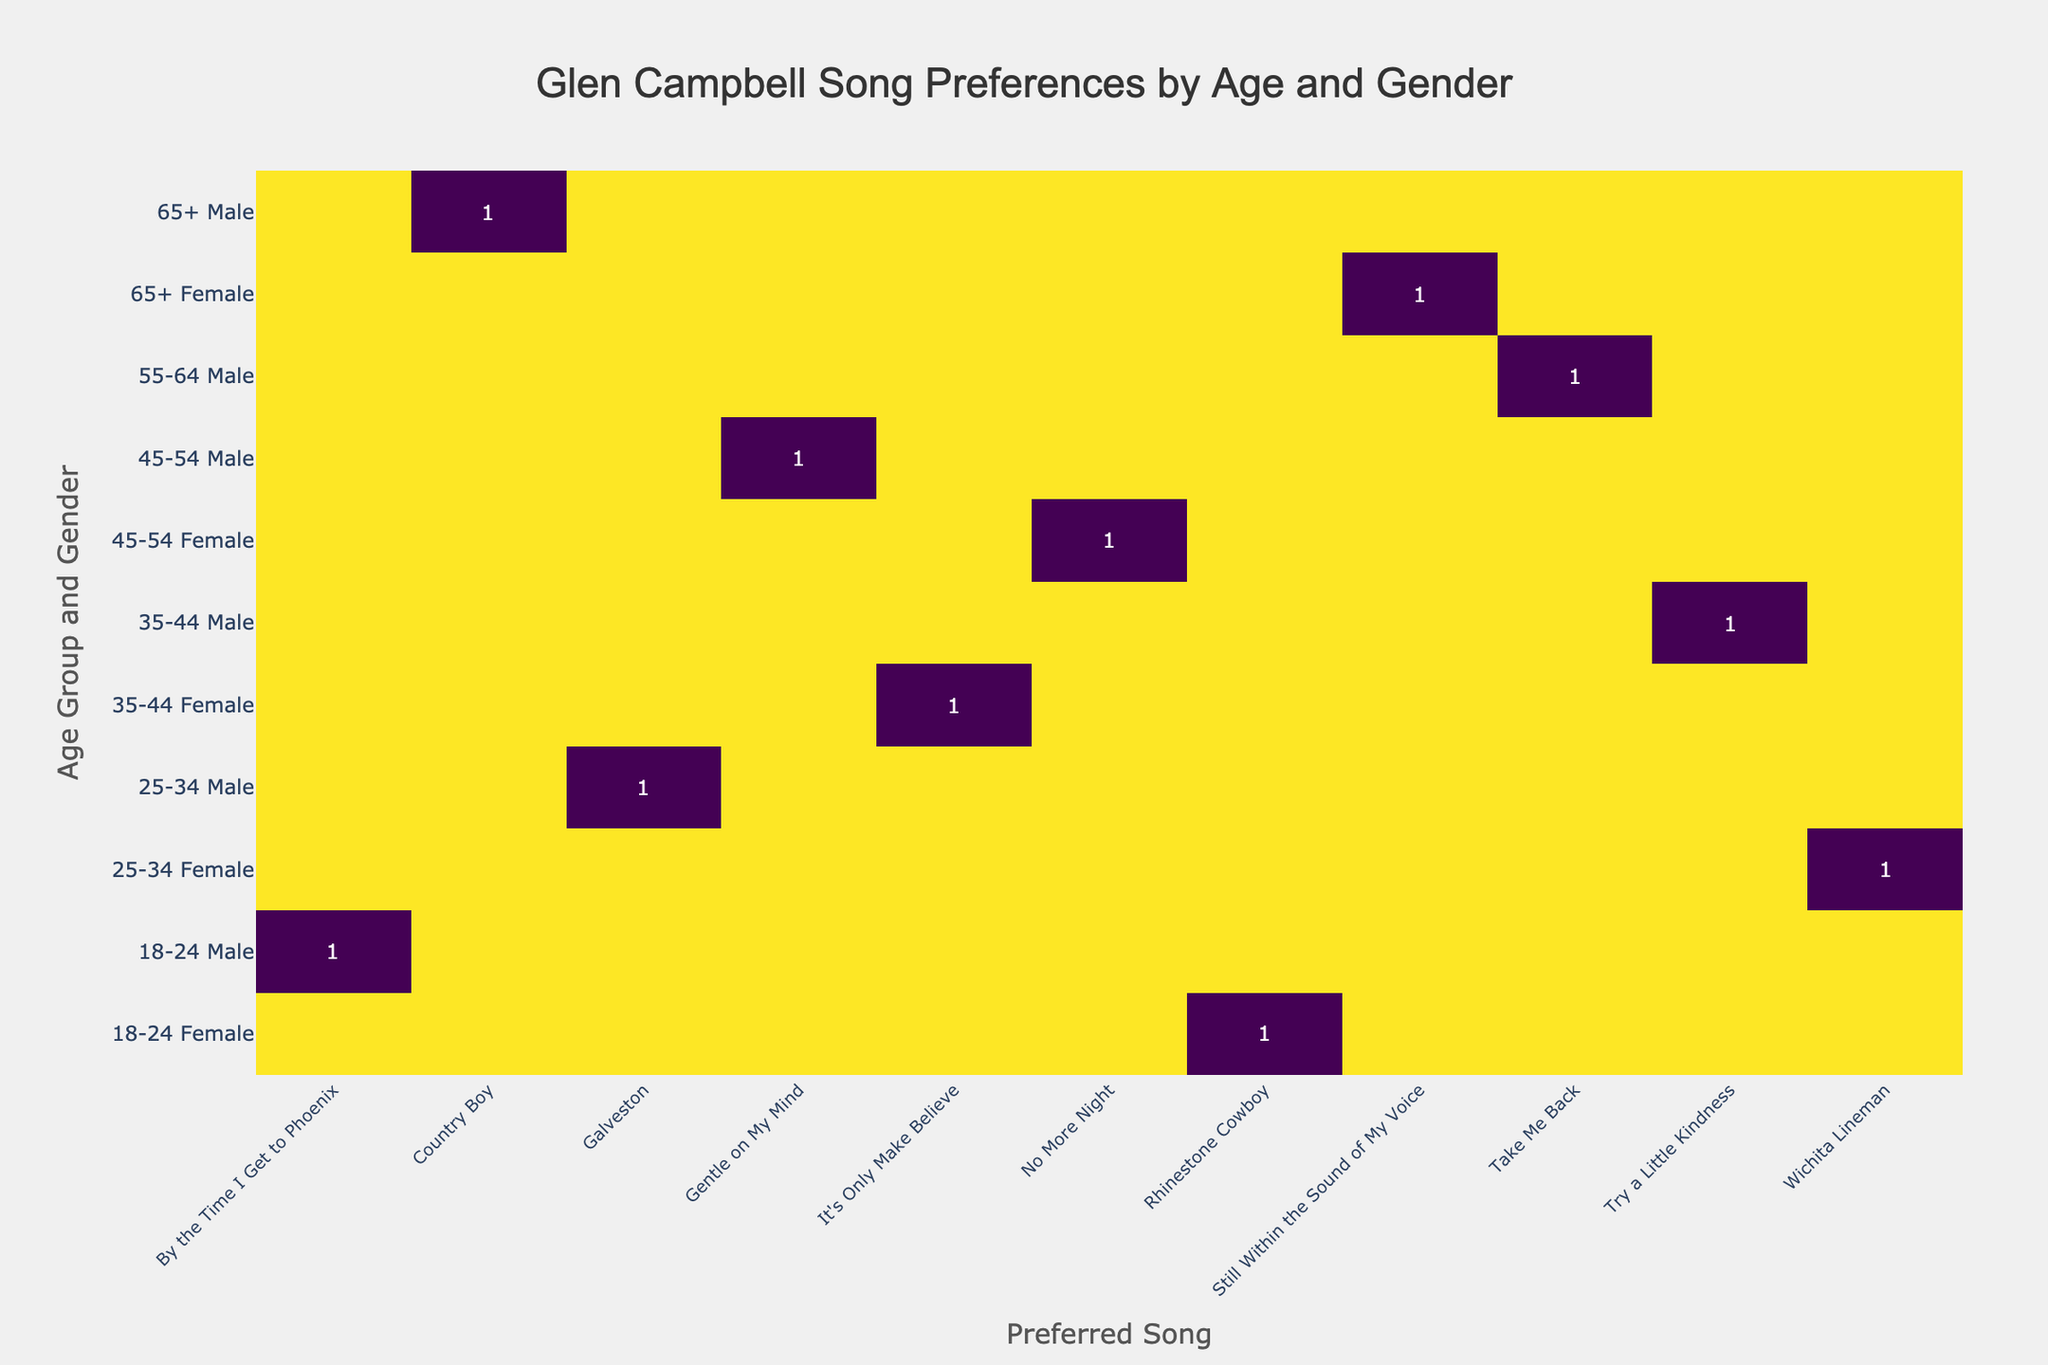What is the preferred song of females in the 18-24 age group? From the table, we look for the row corresponding to the '18-24 Female'. The preferred song listed in that row is 'Rhinestone Cowboy'.
Answer: Rhinestone Cowboy Which age group has the highest preference for 'Galveston'? We look for the song 'Galveston' in the table and see it belongs to the '25-34 Male' demographic. There are no other age groups listed for this song. Thus, 25-34 is the only age group for this song which means it has the highest preference by default.
Answer: 25-34 How many males prefer 'Try a Little Kindness'? Checking the corresponding row for 'Try a Little Kindness', we find that only the '35-44 Male' demographic has expressed this preference, which is indicated by the value 1 in the confusion matrix.
Answer: 1 Is 'Country Boy' preferred more by females than by males? Looking at the table, 'Country Boy' is preferred only by the '65+ Male' group, with no preferences indicated for females. Therefore, since females don’t prefer it at all, it is false that females prefer it more than males.
Answer: No Which song is the most preferred by the oldest age group, 65+? In the row for age group '65+', we have two entries, with males preferring 'Country Boy' and females preferring 'Still Within the Sound of My Voice'. To determine the most preferred song, we see both are preferred equally (1 each), therefore it is tied.
Answer: Tied: Country Boy and Still Within the Sound of My Voice What is the total number of unique songs preferred by males across all age groups? By analyzing the male preferences across all age groups, the songs listed are 'By the Time I Get to Phoenix', 'Galveston', 'Try a Little Kindness', 'Gentle on My Mind', 'Take Me Back', and 'Country Boy'. Counting these gives a total of 6 unique songs.
Answer: 6 Which gender prefers 'It's Only Make Believe'? Looking at the table, 'It's Only Make Believe' is only preferred by the '35-44 Female' demographic. Hence, we can conclude that this song is preferred solely by females.
Answer: Female What is the difference in preferred songs between the 55-64 age group and the 45-54 age group? The '55-64' age group has a preference for 'Take Me Back' while the '45-54' age group prefers 'Gentle on My Mind' and 'No More Night'. Both age groups have one unique song each, thus the difference is 0, indicating no discrepancies in the count of unique preferences between them.
Answer: 0 Which age group contains the least variety in song preferences? By examining the table, it appears that each age group has either one or two preferred songs, but the '65+' age group only has two songs. Since every group has at least two, the 65+ age group has the least variety in that it retains the same count as others but corresponds to only half the gender distributions compared to the others that have two ones consistently for males and females, making it marginally lower.
Answer: 65+ 